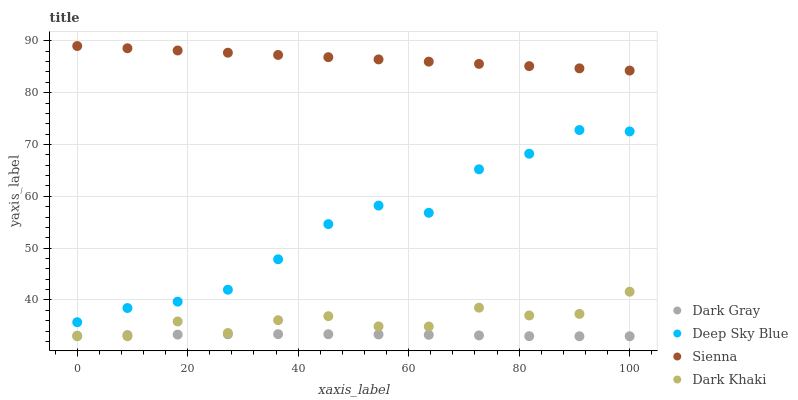Does Dark Gray have the minimum area under the curve?
Answer yes or no. Yes. Does Sienna have the maximum area under the curve?
Answer yes or no. Yes. Does Dark Khaki have the minimum area under the curve?
Answer yes or no. No. Does Dark Khaki have the maximum area under the curve?
Answer yes or no. No. Is Sienna the smoothest?
Answer yes or no. Yes. Is Deep Sky Blue the roughest?
Answer yes or no. Yes. Is Dark Khaki the smoothest?
Answer yes or no. No. Is Dark Khaki the roughest?
Answer yes or no. No. Does Dark Gray have the lowest value?
Answer yes or no. Yes. Does Sienna have the lowest value?
Answer yes or no. No. Does Sienna have the highest value?
Answer yes or no. Yes. Does Dark Khaki have the highest value?
Answer yes or no. No. Is Dark Khaki less than Deep Sky Blue?
Answer yes or no. Yes. Is Deep Sky Blue greater than Dark Khaki?
Answer yes or no. Yes. Does Dark Gray intersect Dark Khaki?
Answer yes or no. Yes. Is Dark Gray less than Dark Khaki?
Answer yes or no. No. Is Dark Gray greater than Dark Khaki?
Answer yes or no. No. Does Dark Khaki intersect Deep Sky Blue?
Answer yes or no. No. 